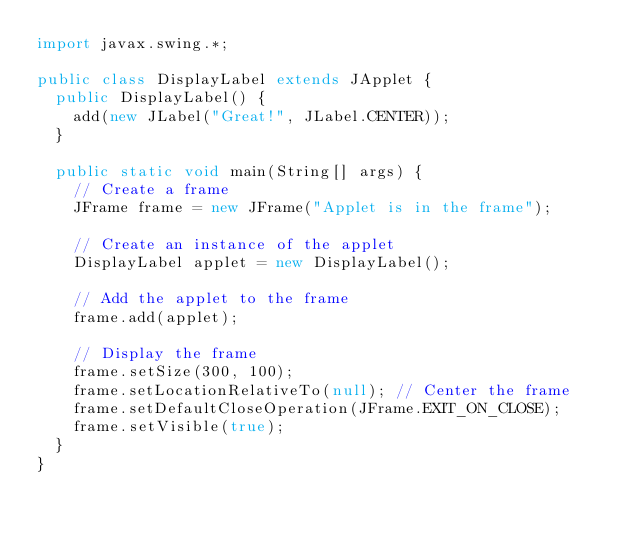<code> <loc_0><loc_0><loc_500><loc_500><_Java_>import javax.swing.*; 

public class DisplayLabel extends JApplet {
  public DisplayLabel() {
    add(new JLabel("Great!", JLabel.CENTER));
  }
  
  public static void main(String[] args) {
    // Create a frame
    JFrame frame = new JFrame("Applet is in the frame");

    // Create an instance of the applet
    DisplayLabel applet = new DisplayLabel();

    // Add the applet to the frame
    frame.add(applet);

    // Display the frame
    frame.setSize(300, 100);
    frame.setLocationRelativeTo(null); // Center the frame   
    frame.setDefaultCloseOperation(JFrame.EXIT_ON_CLOSE);
    frame.setVisible(true);
  }
}
</code> 